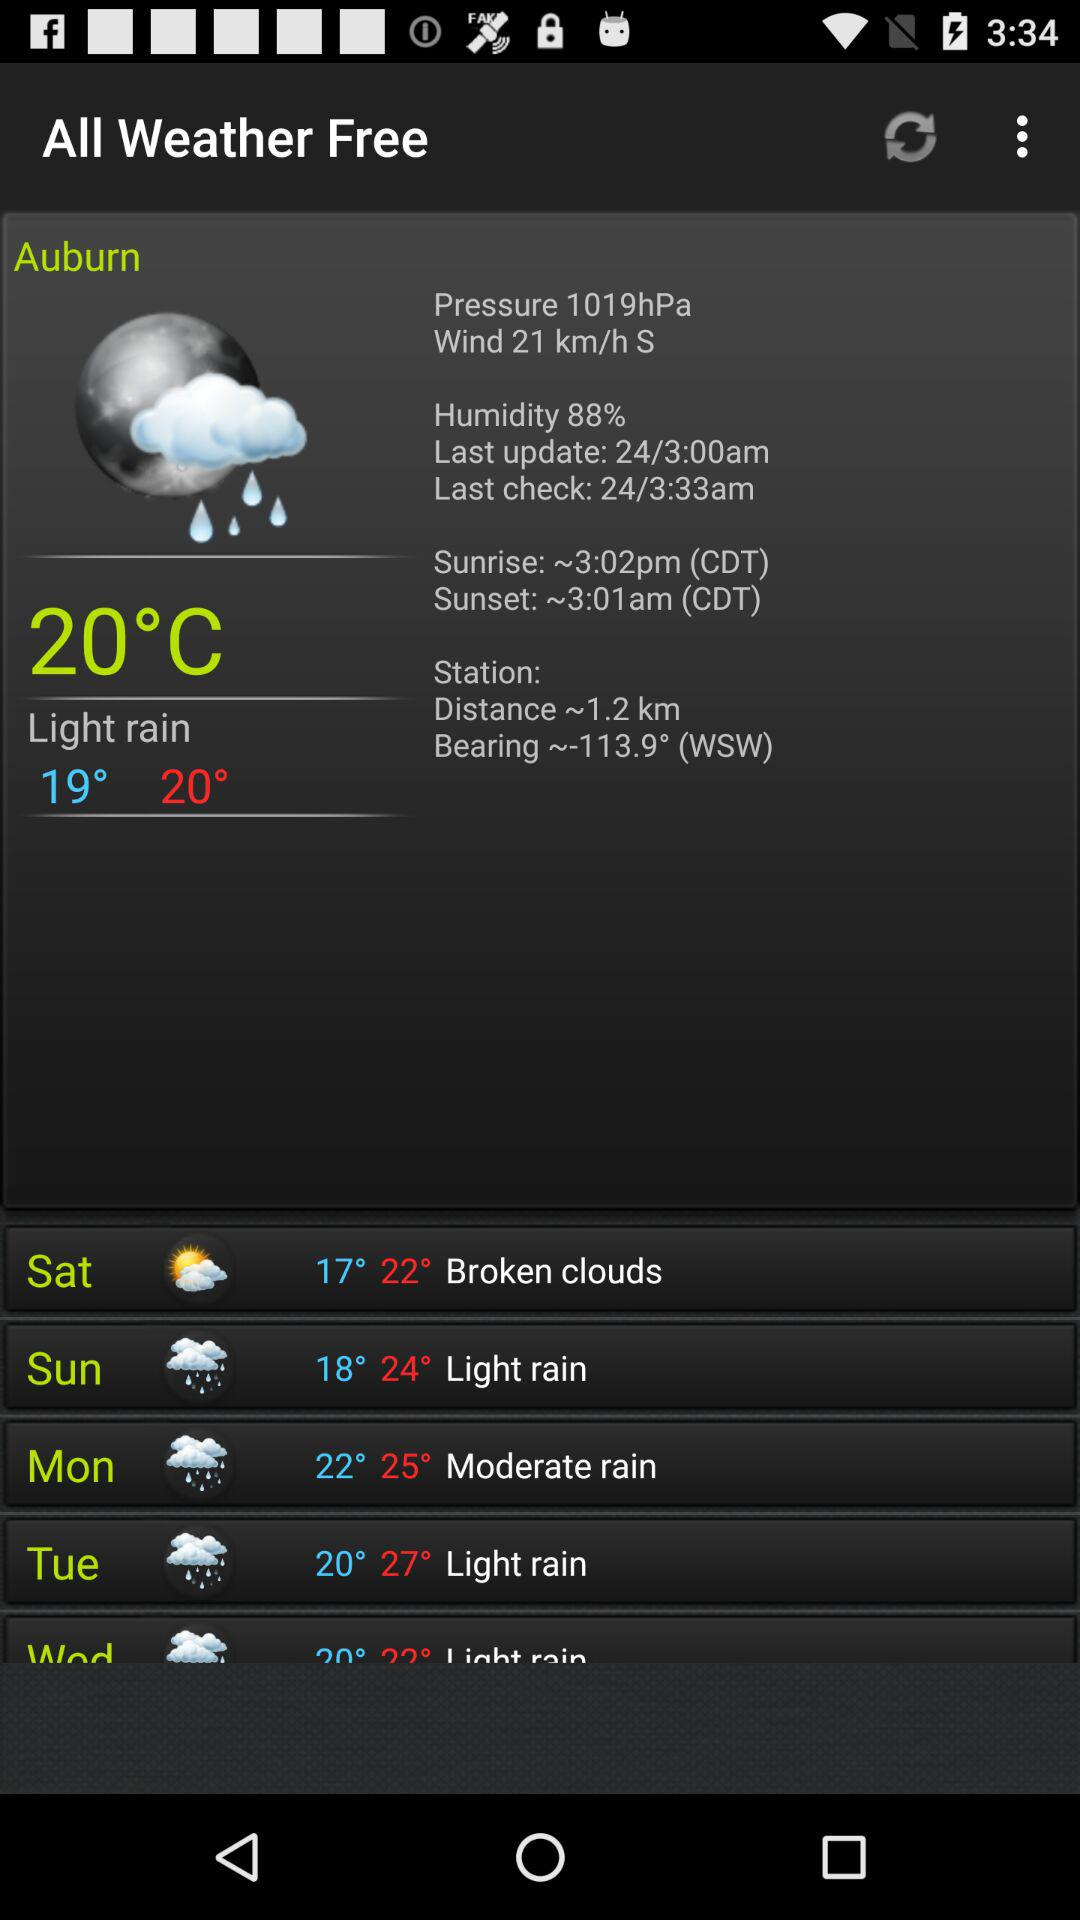What is the last update time? The time of the last update is 24/3:00am. 